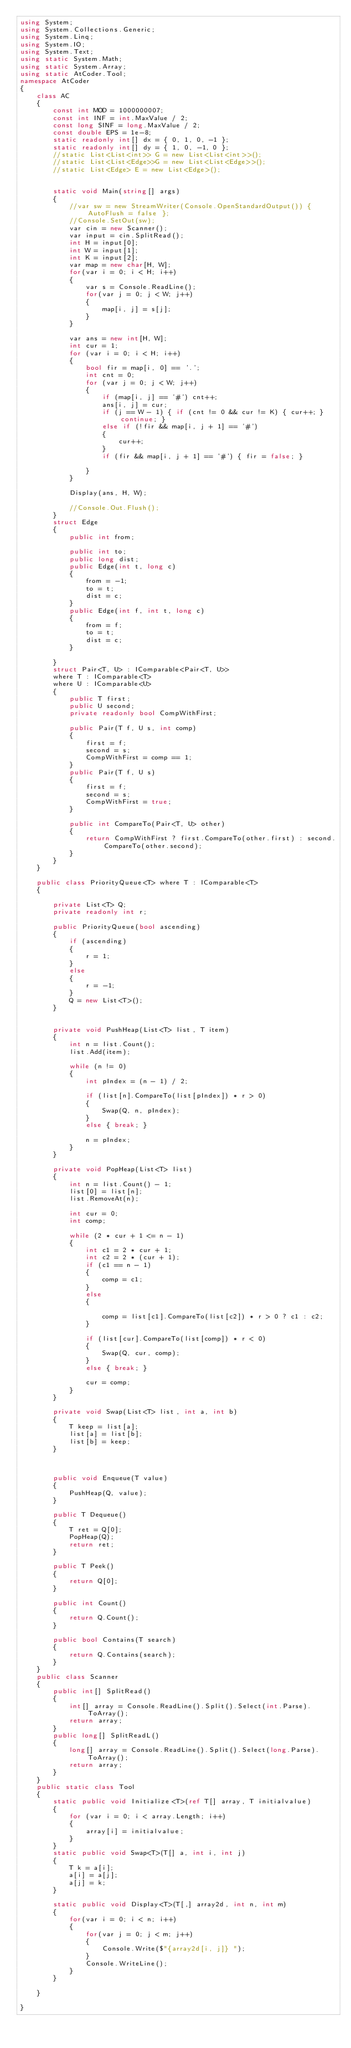<code> <loc_0><loc_0><loc_500><loc_500><_C#_>using System;
using System.Collections.Generic;
using System.Linq;
using System.IO;
using System.Text;
using static System.Math;
using static System.Array;
using static AtCoder.Tool;
namespace AtCoder
{
    class AC
    {
        const int MOD = 1000000007;
        const int INF = int.MaxValue / 2;
        const long SINF = long.MaxValue / 2;
        const double EPS = 1e-8;
        static readonly int[] dx = { 0, 1, 0, -1 };
        static readonly int[] dy = { 1, 0, -1, 0 };
        //static List<List<int>> G = new List<List<int>>();
        //static List<List<Edge>>G = new List<List<Edge>>();
        //static List<Edge> E = new List<Edge>();


        static void Main(string[] args)
        {
            //var sw = new StreamWriter(Console.OpenStandardOutput()) { AutoFlush = false };
            //Console.SetOut(sw);
            var cin = new Scanner();
            var input = cin.SplitRead();
            int H = input[0];
            int W = input[1];
            int K = input[2];
            var map = new char[H, W];
            for(var i = 0; i < H; i++)
            {
                var s = Console.ReadLine();
                for(var j = 0; j < W; j++)
                {
                    map[i, j] = s[j];
                }
            }

            var ans = new int[H, W];
            int cur = 1;
            for (var i = 0; i < H; i++)
            {
                bool fir = map[i, 0] == '.';
                int cnt = 0;
                for (var j = 0; j < W; j++)
                {
                    if (map[i, j] == '#') cnt++;
                    ans[i, j] = cur;
                    if (j == W - 1) { if (cnt != 0 && cur != K) { cur++; } continue; }
                    else if (!fir && map[i, j + 1] == '#')
                    {
                        cur++;
                    }
                    if (fir && map[i, j + 1] == '#') { fir = false; }

                }
            }

            Display(ans, H, W);

            //Console.Out.Flush();
        }
        struct Edge
        {
            public int from;

            public int to;
            public long dist;
            public Edge(int t, long c)
            {
                from = -1;
                to = t;
                dist = c;
            }
            public Edge(int f, int t, long c)
            {
                from = f;
                to = t;
                dist = c;
            }

        }
        struct Pair<T, U> : IComparable<Pair<T, U>>
        where T : IComparable<T>
        where U : IComparable<U>
        {
            public T first;
            public U second;
            private readonly bool CompWithFirst;

            public Pair(T f, U s, int comp)
            {
                first = f;
                second = s;
                CompWithFirst = comp == 1;
            }
            public Pair(T f, U s)
            {
                first = f;
                second = s;
                CompWithFirst = true;
            }

            public int CompareTo(Pair<T, U> other)
            {
                return CompWithFirst ? first.CompareTo(other.first) : second.CompareTo(other.second);
            }
        }
    }
   
    public class PriorityQueue<T> where T : IComparable<T>
    {

        private List<T> Q;
        private readonly int r;

        public PriorityQueue(bool ascending)
        {
            if (ascending)
            {
                r = 1;
            }
            else
            {
                r = -1;
            }
            Q = new List<T>();
        }


        private void PushHeap(List<T> list, T item)
        {
            int n = list.Count();
            list.Add(item);

            while (n != 0)
            {
                int pIndex = (n - 1) / 2;

                if (list[n].CompareTo(list[pIndex]) * r > 0)
                {
                    Swap(Q, n, pIndex);
                }
                else { break; }

                n = pIndex;
            }
        }

        private void PopHeap(List<T> list)
        {
            int n = list.Count() - 1;
            list[0] = list[n];
            list.RemoveAt(n);

            int cur = 0;
            int comp;

            while (2 * cur + 1 <= n - 1)
            {
                int c1 = 2 * cur + 1;
                int c2 = 2 * (cur + 1);
                if (c1 == n - 1)
                {
                    comp = c1;
                }
                else
                {

                    comp = list[c1].CompareTo(list[c2]) * r > 0 ? c1 : c2;
                }

                if (list[cur].CompareTo(list[comp]) * r < 0)
                {
                    Swap(Q, cur, comp);
                }
                else { break; }

                cur = comp;
            }
        }

        private void Swap(List<T> list, int a, int b)
        {
            T keep = list[a];
            list[a] = list[b];
            list[b] = keep;
        }



        public void Enqueue(T value)
        {
            PushHeap(Q, value);
        }

        public T Dequeue()
        {
            T ret = Q[0];
            PopHeap(Q);
            return ret;
        }

        public T Peek()
        {
            return Q[0];
        }

        public int Count()
        {
            return Q.Count();
        }

        public bool Contains(T search)
        {
            return Q.Contains(search);
        }
    }
    public class Scanner
    {
        public int[] SplitRead()
        {
            int[] array = Console.ReadLine().Split().Select(int.Parse).ToArray();
            return array;
        }
        public long[] SplitReadL()
        {
            long[] array = Console.ReadLine().Split().Select(long.Parse).ToArray();
            return array;
        }
    }
    public static class Tool
    {
        static public void Initialize<T>(ref T[] array, T initialvalue)
        {
            for (var i = 0; i < array.Length; i++)
            {
                array[i] = initialvalue;
            }
        }
        static public void Swap<T>(T[] a, int i, int j)
        {
            T k = a[i];
            a[i] = a[j];
            a[j] = k;
        }

        static public void Display<T>(T[,] array2d, int n, int m)
        {
            for(var i = 0; i < n; i++)
            {
                for(var j = 0; j < m; j++)
                {
                    Console.Write($"{array2d[i, j]} ");
                }
                Console.WriteLine();
            }
        }

    }

}
</code> 